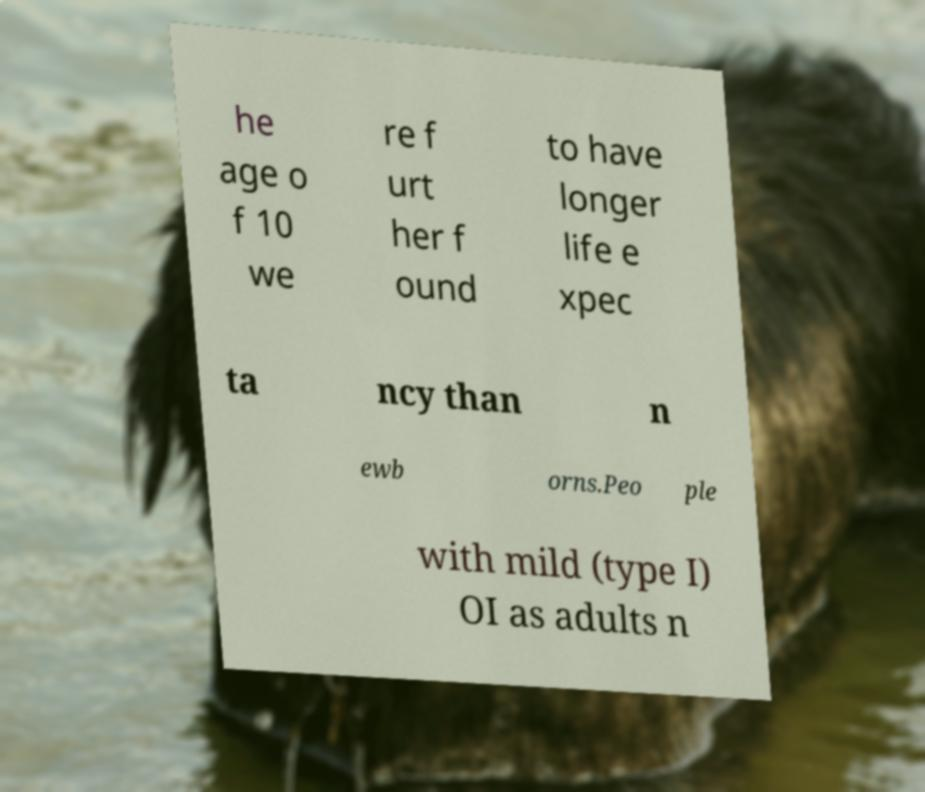For documentation purposes, I need the text within this image transcribed. Could you provide that? he age o f 10 we re f urt her f ound to have longer life e xpec ta ncy than n ewb orns.Peo ple with mild (type I) OI as adults n 